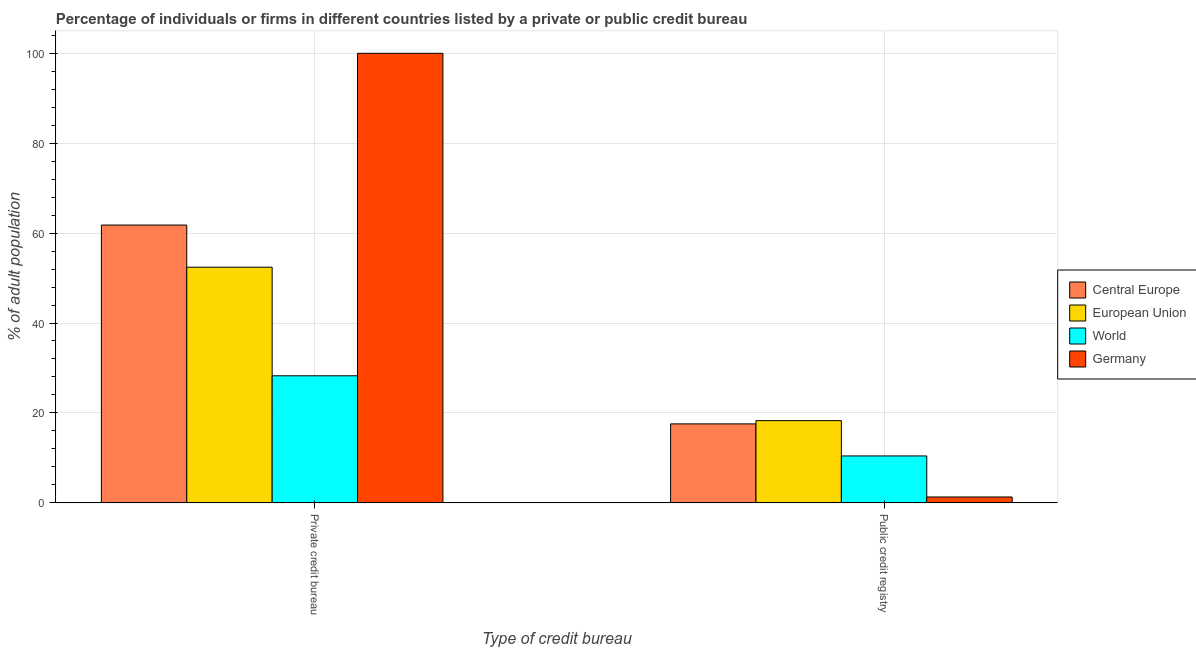Are the number of bars per tick equal to the number of legend labels?
Make the answer very short. Yes. How many bars are there on the 1st tick from the left?
Offer a terse response. 4. What is the label of the 2nd group of bars from the left?
Keep it short and to the point. Public credit registry. What is the percentage of firms listed by public credit bureau in European Union?
Your response must be concise. 18.29. Across all countries, what is the maximum percentage of firms listed by public credit bureau?
Make the answer very short. 18.29. Across all countries, what is the minimum percentage of firms listed by private credit bureau?
Offer a terse response. 28.26. In which country was the percentage of firms listed by public credit bureau minimum?
Offer a terse response. Germany. What is the total percentage of firms listed by private credit bureau in the graph?
Keep it short and to the point. 242.47. What is the difference between the percentage of firms listed by private credit bureau in World and that in European Union?
Provide a succinct answer. -24.16. What is the difference between the percentage of firms listed by private credit bureau in Central Europe and the percentage of firms listed by public credit bureau in European Union?
Keep it short and to the point. 43.51. What is the average percentage of firms listed by private credit bureau per country?
Provide a short and direct response. 60.62. What is the difference between the percentage of firms listed by public credit bureau and percentage of firms listed by private credit bureau in World?
Keep it short and to the point. -17.83. What is the ratio of the percentage of firms listed by public credit bureau in Central Europe to that in Germany?
Offer a very short reply. 13.51. What does the 4th bar from the left in Public credit registry represents?
Provide a succinct answer. Germany. How many bars are there?
Offer a terse response. 8. How many countries are there in the graph?
Make the answer very short. 4. Does the graph contain grids?
Give a very brief answer. Yes. Where does the legend appear in the graph?
Offer a very short reply. Center right. What is the title of the graph?
Your response must be concise. Percentage of individuals or firms in different countries listed by a private or public credit bureau. Does "Mauritius" appear as one of the legend labels in the graph?
Provide a succinct answer. No. What is the label or title of the X-axis?
Provide a succinct answer. Type of credit bureau. What is the label or title of the Y-axis?
Make the answer very short. % of adult population. What is the % of adult population in Central Europe in Private credit bureau?
Your response must be concise. 61.79. What is the % of adult population in European Union in Private credit bureau?
Provide a short and direct response. 52.42. What is the % of adult population of World in Private credit bureau?
Offer a very short reply. 28.26. What is the % of adult population in Germany in Private credit bureau?
Give a very brief answer. 100. What is the % of adult population in Central Europe in Public credit registry?
Offer a very short reply. 17.56. What is the % of adult population of European Union in Public credit registry?
Keep it short and to the point. 18.29. What is the % of adult population of World in Public credit registry?
Your answer should be very brief. 10.43. What is the % of adult population of Germany in Public credit registry?
Provide a succinct answer. 1.3. Across all Type of credit bureau, what is the maximum % of adult population in Central Europe?
Provide a short and direct response. 61.79. Across all Type of credit bureau, what is the maximum % of adult population of European Union?
Offer a very short reply. 52.42. Across all Type of credit bureau, what is the maximum % of adult population of World?
Your answer should be very brief. 28.26. Across all Type of credit bureau, what is the maximum % of adult population in Germany?
Provide a short and direct response. 100. Across all Type of credit bureau, what is the minimum % of adult population in Central Europe?
Offer a terse response. 17.56. Across all Type of credit bureau, what is the minimum % of adult population in European Union?
Keep it short and to the point. 18.29. Across all Type of credit bureau, what is the minimum % of adult population of World?
Make the answer very short. 10.43. Across all Type of credit bureau, what is the minimum % of adult population in Germany?
Offer a very short reply. 1.3. What is the total % of adult population in Central Europe in the graph?
Offer a terse response. 79.35. What is the total % of adult population of European Union in the graph?
Give a very brief answer. 70.7. What is the total % of adult population of World in the graph?
Provide a short and direct response. 38.69. What is the total % of adult population of Germany in the graph?
Make the answer very short. 101.3. What is the difference between the % of adult population in Central Europe in Private credit bureau and that in Public credit registry?
Give a very brief answer. 44.23. What is the difference between the % of adult population in European Union in Private credit bureau and that in Public credit registry?
Offer a terse response. 34.13. What is the difference between the % of adult population in World in Private credit bureau and that in Public credit registry?
Your answer should be very brief. 17.83. What is the difference between the % of adult population in Germany in Private credit bureau and that in Public credit registry?
Offer a terse response. 98.7. What is the difference between the % of adult population in Central Europe in Private credit bureau and the % of adult population in European Union in Public credit registry?
Make the answer very short. 43.51. What is the difference between the % of adult population in Central Europe in Private credit bureau and the % of adult population in World in Public credit registry?
Provide a short and direct response. 51.36. What is the difference between the % of adult population of Central Europe in Private credit bureau and the % of adult population of Germany in Public credit registry?
Make the answer very short. 60.49. What is the difference between the % of adult population of European Union in Private credit bureau and the % of adult population of World in Public credit registry?
Give a very brief answer. 41.99. What is the difference between the % of adult population of European Union in Private credit bureau and the % of adult population of Germany in Public credit registry?
Your answer should be compact. 51.12. What is the difference between the % of adult population of World in Private credit bureau and the % of adult population of Germany in Public credit registry?
Offer a terse response. 26.96. What is the average % of adult population in Central Europe per Type of credit bureau?
Your answer should be compact. 39.68. What is the average % of adult population of European Union per Type of credit bureau?
Provide a short and direct response. 35.35. What is the average % of adult population of World per Type of credit bureau?
Your answer should be compact. 19.35. What is the average % of adult population in Germany per Type of credit bureau?
Offer a terse response. 50.65. What is the difference between the % of adult population of Central Europe and % of adult population of European Union in Private credit bureau?
Make the answer very short. 9.37. What is the difference between the % of adult population of Central Europe and % of adult population of World in Private credit bureau?
Offer a very short reply. 33.53. What is the difference between the % of adult population of Central Europe and % of adult population of Germany in Private credit bureau?
Provide a succinct answer. -38.21. What is the difference between the % of adult population in European Union and % of adult population in World in Private credit bureau?
Make the answer very short. 24.16. What is the difference between the % of adult population in European Union and % of adult population in Germany in Private credit bureau?
Your answer should be compact. -47.58. What is the difference between the % of adult population in World and % of adult population in Germany in Private credit bureau?
Provide a short and direct response. -71.74. What is the difference between the % of adult population of Central Europe and % of adult population of European Union in Public credit registry?
Ensure brevity in your answer.  -0.72. What is the difference between the % of adult population in Central Europe and % of adult population in World in Public credit registry?
Provide a short and direct response. 7.13. What is the difference between the % of adult population of Central Europe and % of adult population of Germany in Public credit registry?
Offer a very short reply. 16.26. What is the difference between the % of adult population in European Union and % of adult population in World in Public credit registry?
Keep it short and to the point. 7.86. What is the difference between the % of adult population of European Union and % of adult population of Germany in Public credit registry?
Offer a terse response. 16.99. What is the difference between the % of adult population in World and % of adult population in Germany in Public credit registry?
Your answer should be very brief. 9.13. What is the ratio of the % of adult population in Central Europe in Private credit bureau to that in Public credit registry?
Your answer should be very brief. 3.52. What is the ratio of the % of adult population of European Union in Private credit bureau to that in Public credit registry?
Ensure brevity in your answer.  2.87. What is the ratio of the % of adult population of World in Private credit bureau to that in Public credit registry?
Provide a succinct answer. 2.71. What is the ratio of the % of adult population of Germany in Private credit bureau to that in Public credit registry?
Provide a succinct answer. 76.92. What is the difference between the highest and the second highest % of adult population in Central Europe?
Your response must be concise. 44.23. What is the difference between the highest and the second highest % of adult population in European Union?
Keep it short and to the point. 34.13. What is the difference between the highest and the second highest % of adult population of World?
Offer a very short reply. 17.83. What is the difference between the highest and the second highest % of adult population in Germany?
Keep it short and to the point. 98.7. What is the difference between the highest and the lowest % of adult population of Central Europe?
Your response must be concise. 44.23. What is the difference between the highest and the lowest % of adult population in European Union?
Offer a very short reply. 34.13. What is the difference between the highest and the lowest % of adult population of World?
Offer a terse response. 17.83. What is the difference between the highest and the lowest % of adult population of Germany?
Your answer should be compact. 98.7. 